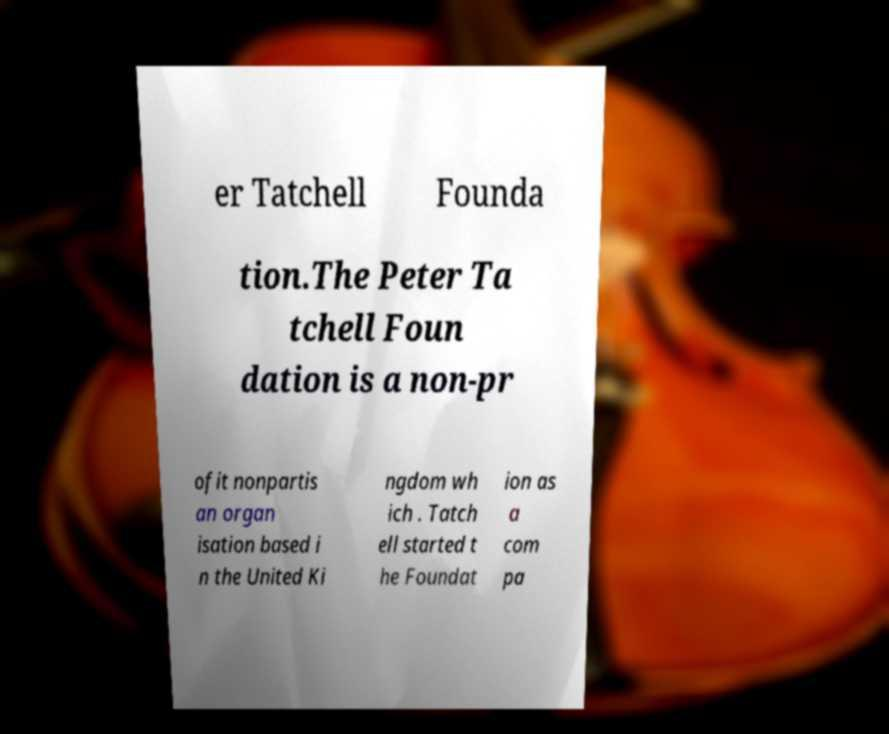Could you extract and type out the text from this image? er Tatchell Founda tion.The Peter Ta tchell Foun dation is a non-pr ofit nonpartis an organ isation based i n the United Ki ngdom wh ich . Tatch ell started t he Foundat ion as a com pa 